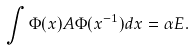Convert formula to latex. <formula><loc_0><loc_0><loc_500><loc_500>\int \Phi ( x ) A \Phi ( x ^ { - 1 } ) d x = \alpha E .</formula> 